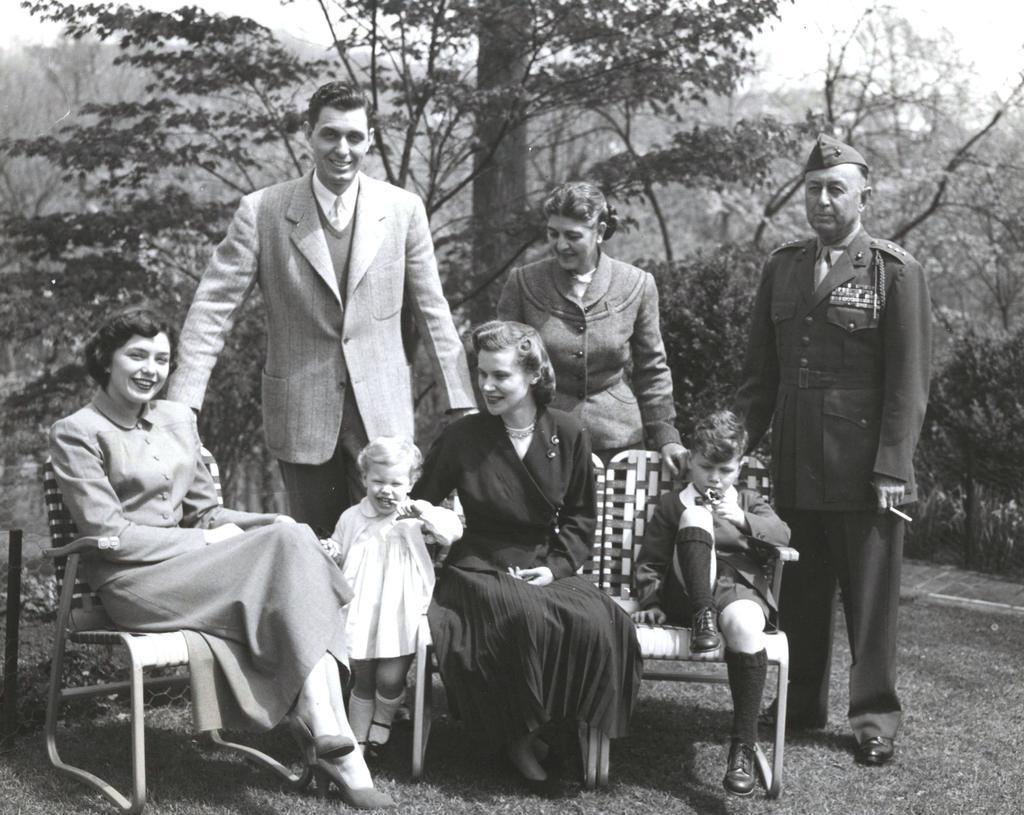Please provide a concise description of this image. This is a black and white photograph, in this photograph there are two women and a kid sitting in a chair, besides the women there is a girl child standing, behind them there are three people standing, in the background of the image there are trees. 